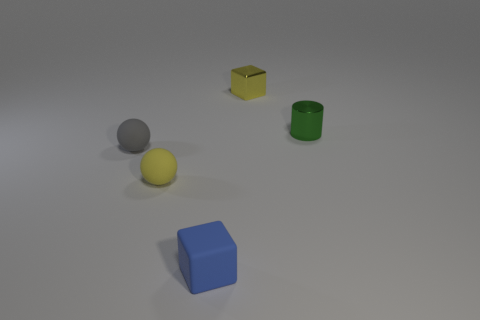Does the arrangement of objects suggest any particular pattern or is it random? The arrangement appears to be random without any discernible pattern. The objects are scattered across the surface without any obvious order or configuration. 